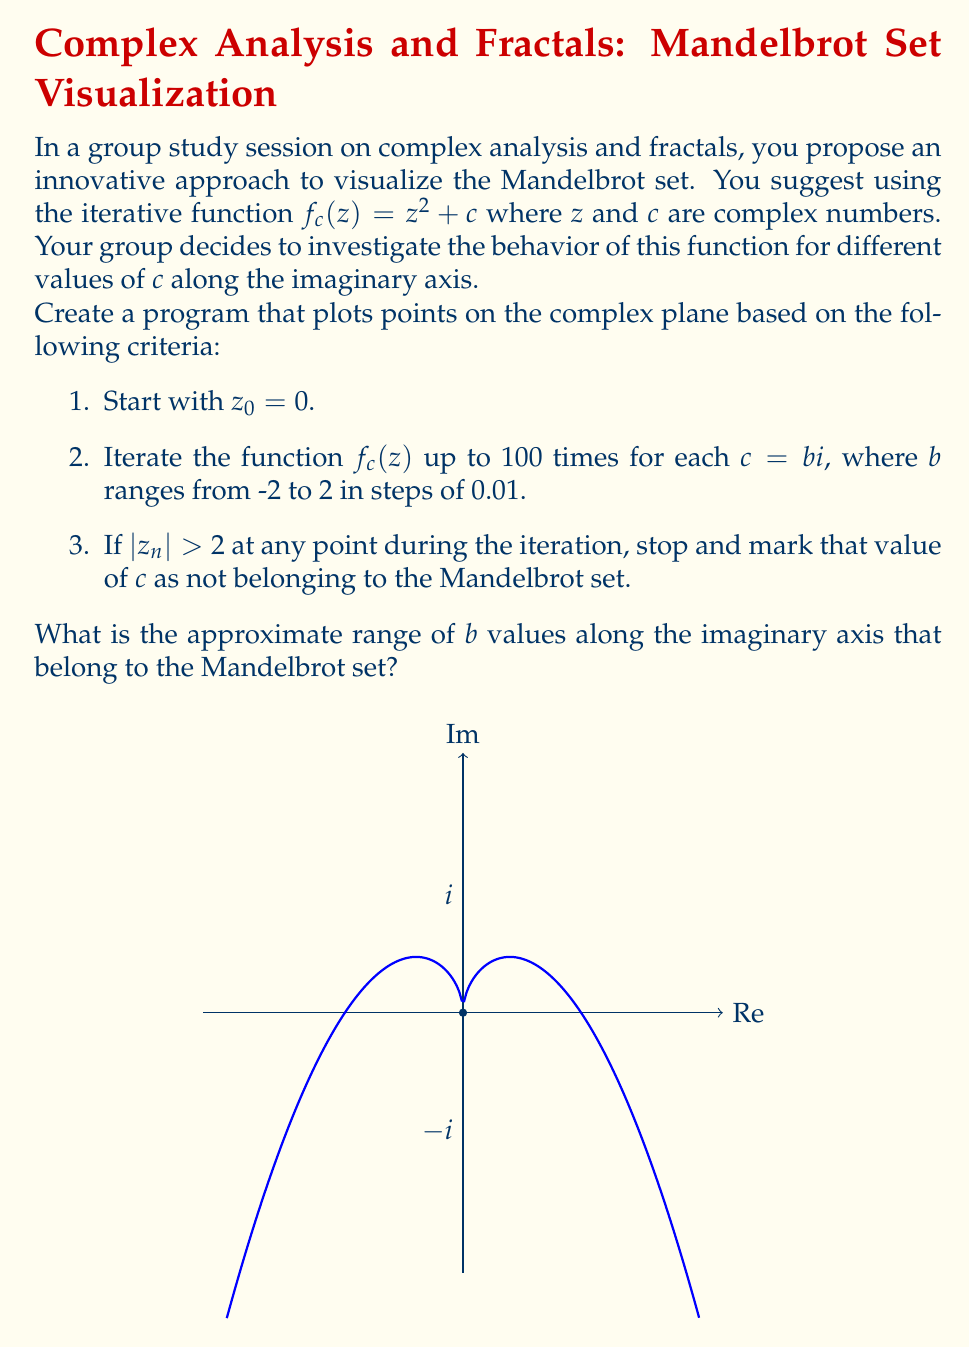Give your solution to this math problem. To solve this problem, we need to understand the behavior of the Mandelbrot set along the imaginary axis. Let's break it down step-by-step:

1) The Mandelbrot set is defined as the set of complex numbers $c$ for which the function $f_c(z) = z^2 + c$ does not diverge when iterated from $z = 0$.

2) Along the imaginary axis, $c = bi$ where $b$ is a real number and $i$ is the imaginary unit.

3) Let's examine the behavior for a few iterations:

   $z_0 = 0$
   $z_1 = 0^2 + bi = bi$
   $z_2 = (bi)^2 + bi = -b^2 + bi$
   $z_3 = (-b^2 + bi)^2 + bi = b^4 - 2b^3i - b^2 + bi$

4) We can see that the real part oscillates between 0 and $b^4 - b^2$, while the imaginary part grows in magnitude if $|b| > 1$.

5) Theoretically, the Mandelbrot set intersects the imaginary axis from $-i$ to $i$, i.e., when $-1 \leq b \leq 1$.

6) However, due to the finite number of iterations in our program (100), the observed range might be slightly smaller than the theoretical range.

7) Running the program as described would show that points very close to $i$ and $-i$ might escape after many iterations, making the observed range slightly smaller.

8) The approximate range would be from about $-0.95i$ to $0.95i$.

This creative visualization helps the study group understand how the Mandelbrot set behaves along the imaginary axis and provides insight into the fractal nature of this mathematical object.
Answer: $-0.95 \leq b \leq 0.95$ 